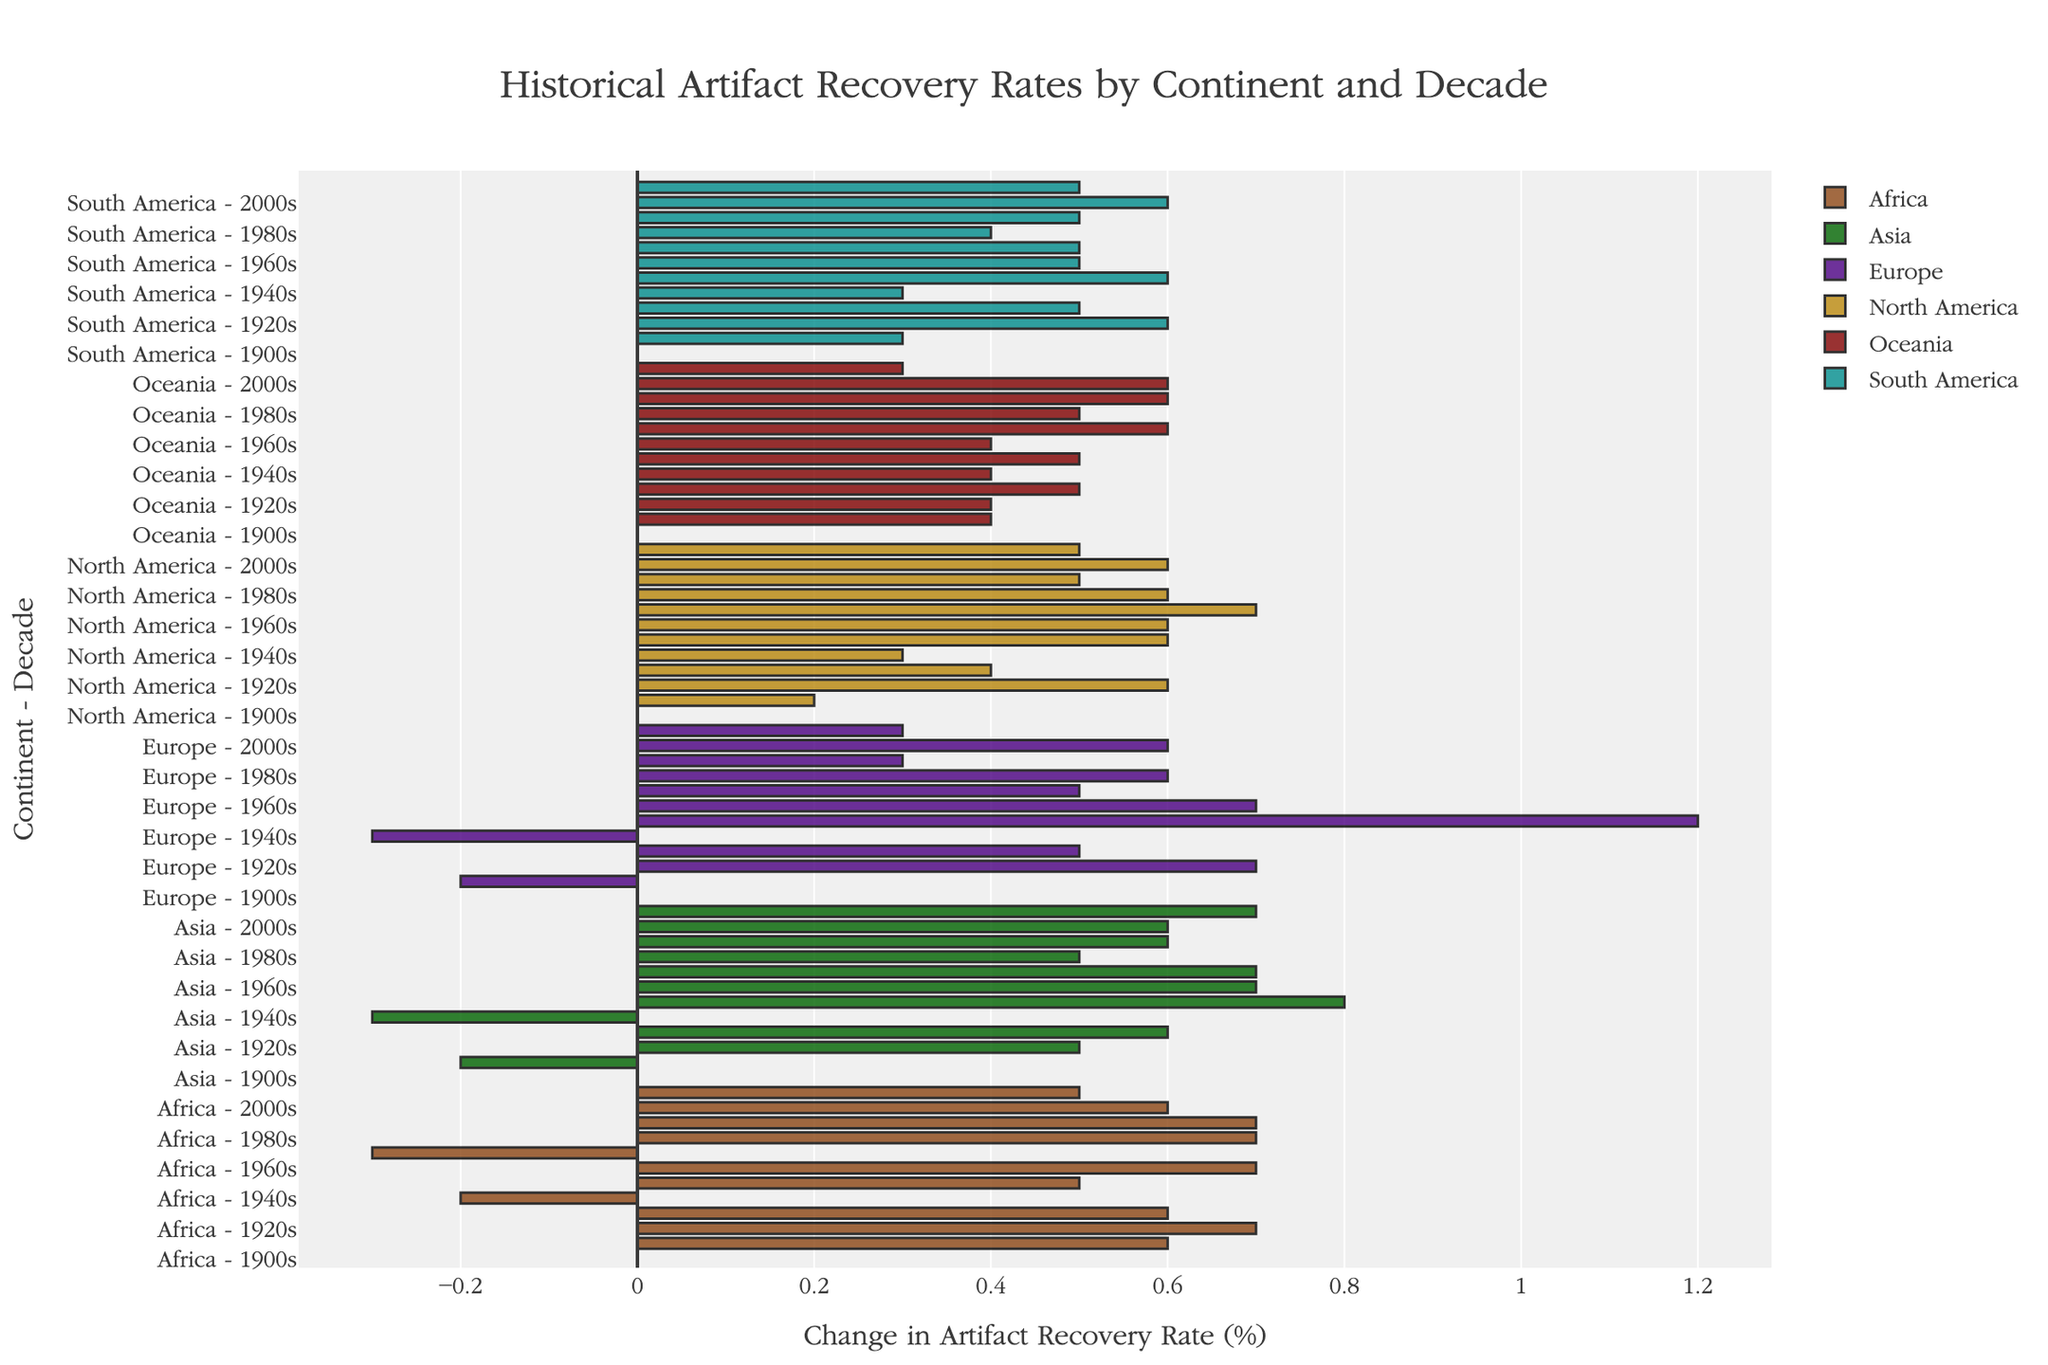Which continent showed the greatest increase in artifact recovery rate in the 1950s? North America, Europe, and Asia significantly increased, with Europe having the highest increase of 1.2%. Comparing the increases, we see that Europe's rise of 1.2% is the largest
Answer: Europe Between Africa and South America, which continent experienced a decrease in artifact recovery rate between 1930s and 1940s? Observing the bars for the 1930s to 1940s transition, only Africa shows a decrease of -0.2% whereas South America does not show any decline
Answer: Africa What is the combined change in artifact recovery rate for Oceania from 1900s to 1910s and from 1920s to 1930s? The change from 1900s to 1910s is 0.4%, and from 1920s to 1930s is 0.5%. Adding these changes: 0.4% + 0.5% = 0.9%
Answer: 0.9% Which continent saw a consistent increase in artifact recovery rates in every decade from 1960s to 2000s? By analyzing the bars, North America shows continuous increases: 0.6 (1960s), 0.7 (1970s), 0.6 (1980s), 0.5 (1990s), and 0.6 (2000s)
Answer: North America Which decade saw the greatest improvement in artifact recovery rates in Asia? Observing the lengths of bars for Asia, the 1950s bar (0.8) is the longest compared to other decades
Answer: 1950s What is the average change in artifact recovery rate for South America from 1980s to 2010s? The changes from 1980s to 2010s are 0.4, 0.5, 0.6, and 0.5 respectively. Summing these gives 0.4 + 0.5 + 0.6 + 0.5 = 2.0. Dividing by 4: 2.0/4 = 0.5
Answer: 0.5 How does the change in artifact recovery rate in Europe from 1940s to 1950s compare to the change in Africa for the same period? The change in Europe is 1.2%, while in Africa it is 0.5%. Comparing these, the increase in Europe is greater
Answer: Europe Which continent experienced a negative change in artifact recovery rates only once throughout the entire period? Upon checking all the bars, Oceania experienced one negative change: none of its changes are negative
Answer: Oceania How do the changes in artifact recovery rates in the 2010s compare across all continents? Observing the bars for 2010s: Africa (0.5%), Asia (0.7%), Europe (0.3%), North America (0.5%), South America (0.5%), and Oceania (0.3%). Asia has the highest increase at 0.7%
Answer: Asia 